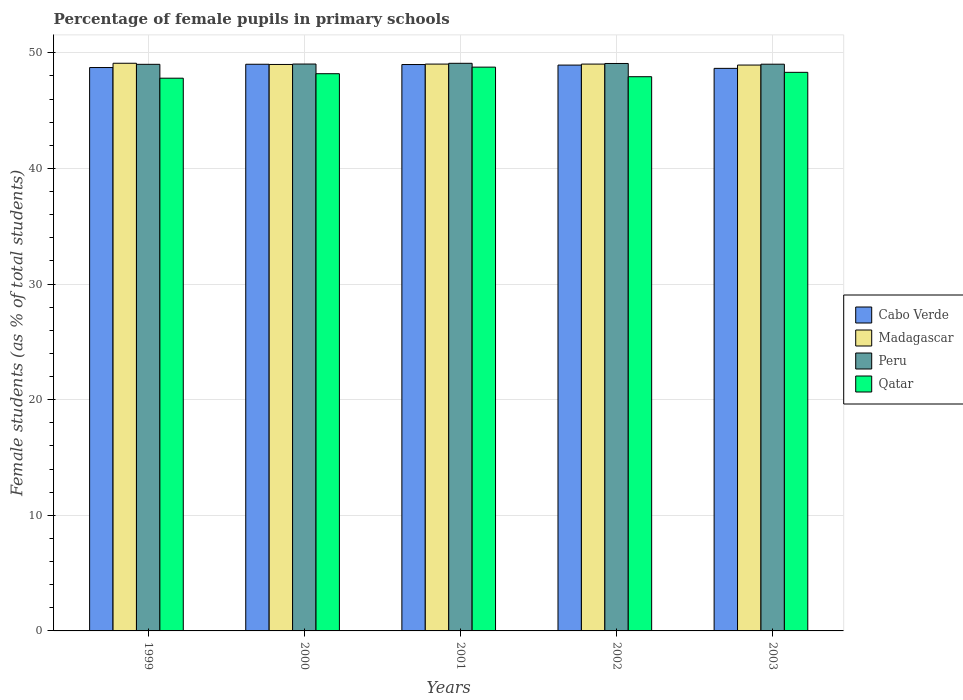Are the number of bars on each tick of the X-axis equal?
Ensure brevity in your answer.  Yes. What is the percentage of female pupils in primary schools in Peru in 2003?
Provide a short and direct response. 49.02. Across all years, what is the maximum percentage of female pupils in primary schools in Madagascar?
Ensure brevity in your answer.  49.1. Across all years, what is the minimum percentage of female pupils in primary schools in Cabo Verde?
Keep it short and to the point. 48.66. In which year was the percentage of female pupils in primary schools in Qatar minimum?
Give a very brief answer. 1999. What is the total percentage of female pupils in primary schools in Cabo Verde in the graph?
Your response must be concise. 244.34. What is the difference between the percentage of female pupils in primary schools in Qatar in 1999 and that in 2000?
Provide a succinct answer. -0.39. What is the difference between the percentage of female pupils in primary schools in Qatar in 2002 and the percentage of female pupils in primary schools in Peru in 1999?
Your answer should be very brief. -1.07. What is the average percentage of female pupils in primary schools in Qatar per year?
Keep it short and to the point. 48.21. In the year 2003, what is the difference between the percentage of female pupils in primary schools in Qatar and percentage of female pupils in primary schools in Cabo Verde?
Keep it short and to the point. -0.34. In how many years, is the percentage of female pupils in primary schools in Qatar greater than 44 %?
Provide a short and direct response. 5. What is the ratio of the percentage of female pupils in primary schools in Cabo Verde in 2000 to that in 2002?
Give a very brief answer. 1. What is the difference between the highest and the second highest percentage of female pupils in primary schools in Cabo Verde?
Provide a short and direct response. 0.02. What is the difference between the highest and the lowest percentage of female pupils in primary schools in Cabo Verde?
Your response must be concise. 0.36. In how many years, is the percentage of female pupils in primary schools in Qatar greater than the average percentage of female pupils in primary schools in Qatar taken over all years?
Offer a very short reply. 2. Is it the case that in every year, the sum of the percentage of female pupils in primary schools in Peru and percentage of female pupils in primary schools in Cabo Verde is greater than the sum of percentage of female pupils in primary schools in Madagascar and percentage of female pupils in primary schools in Qatar?
Ensure brevity in your answer.  Yes. What does the 1st bar from the left in 2003 represents?
Make the answer very short. Cabo Verde. What does the 4th bar from the right in 2001 represents?
Your answer should be compact. Cabo Verde. Is it the case that in every year, the sum of the percentage of female pupils in primary schools in Madagascar and percentage of female pupils in primary schools in Peru is greater than the percentage of female pupils in primary schools in Cabo Verde?
Your answer should be very brief. Yes. How many bars are there?
Offer a terse response. 20. How many years are there in the graph?
Your answer should be compact. 5. How many legend labels are there?
Your answer should be very brief. 4. What is the title of the graph?
Keep it short and to the point. Percentage of female pupils in primary schools. What is the label or title of the X-axis?
Provide a succinct answer. Years. What is the label or title of the Y-axis?
Your answer should be very brief. Female students (as % of total students). What is the Female students (as % of total students) of Cabo Verde in 1999?
Your answer should be compact. 48.73. What is the Female students (as % of total students) of Madagascar in 1999?
Your answer should be compact. 49.1. What is the Female students (as % of total students) of Peru in 1999?
Your answer should be very brief. 49.01. What is the Female students (as % of total students) of Qatar in 1999?
Keep it short and to the point. 47.81. What is the Female students (as % of total students) in Cabo Verde in 2000?
Your answer should be very brief. 49.01. What is the Female students (as % of total students) of Madagascar in 2000?
Offer a very short reply. 49. What is the Female students (as % of total students) of Peru in 2000?
Make the answer very short. 49.03. What is the Female students (as % of total students) of Qatar in 2000?
Offer a very short reply. 48.2. What is the Female students (as % of total students) of Cabo Verde in 2001?
Provide a succinct answer. 48.99. What is the Female students (as % of total students) in Madagascar in 2001?
Keep it short and to the point. 49.03. What is the Female students (as % of total students) in Peru in 2001?
Your answer should be compact. 49.1. What is the Female students (as % of total students) in Qatar in 2001?
Offer a very short reply. 48.77. What is the Female students (as % of total students) in Cabo Verde in 2002?
Offer a terse response. 48.94. What is the Female students (as % of total students) in Madagascar in 2002?
Offer a terse response. 49.03. What is the Female students (as % of total students) in Peru in 2002?
Provide a succinct answer. 49.08. What is the Female students (as % of total students) in Qatar in 2002?
Offer a very short reply. 47.94. What is the Female students (as % of total students) in Cabo Verde in 2003?
Offer a very short reply. 48.66. What is the Female students (as % of total students) of Madagascar in 2003?
Offer a very short reply. 48.95. What is the Female students (as % of total students) in Peru in 2003?
Your answer should be compact. 49.02. What is the Female students (as % of total students) in Qatar in 2003?
Your answer should be very brief. 48.32. Across all years, what is the maximum Female students (as % of total students) of Cabo Verde?
Provide a succinct answer. 49.01. Across all years, what is the maximum Female students (as % of total students) in Madagascar?
Provide a short and direct response. 49.1. Across all years, what is the maximum Female students (as % of total students) of Peru?
Offer a terse response. 49.1. Across all years, what is the maximum Female students (as % of total students) in Qatar?
Make the answer very short. 48.77. Across all years, what is the minimum Female students (as % of total students) in Cabo Verde?
Offer a terse response. 48.66. Across all years, what is the minimum Female students (as % of total students) in Madagascar?
Offer a terse response. 48.95. Across all years, what is the minimum Female students (as % of total students) in Peru?
Give a very brief answer. 49.01. Across all years, what is the minimum Female students (as % of total students) in Qatar?
Your response must be concise. 47.81. What is the total Female students (as % of total students) in Cabo Verde in the graph?
Ensure brevity in your answer.  244.34. What is the total Female students (as % of total students) in Madagascar in the graph?
Offer a very short reply. 245.1. What is the total Female students (as % of total students) in Peru in the graph?
Make the answer very short. 245.24. What is the total Female students (as % of total students) in Qatar in the graph?
Make the answer very short. 241.03. What is the difference between the Female students (as % of total students) of Cabo Verde in 1999 and that in 2000?
Give a very brief answer. -0.28. What is the difference between the Female students (as % of total students) in Madagascar in 1999 and that in 2000?
Provide a short and direct response. 0.1. What is the difference between the Female students (as % of total students) of Peru in 1999 and that in 2000?
Ensure brevity in your answer.  -0.02. What is the difference between the Female students (as % of total students) of Qatar in 1999 and that in 2000?
Your response must be concise. -0.39. What is the difference between the Female students (as % of total students) of Cabo Verde in 1999 and that in 2001?
Keep it short and to the point. -0.26. What is the difference between the Female students (as % of total students) in Madagascar in 1999 and that in 2001?
Keep it short and to the point. 0.07. What is the difference between the Female students (as % of total students) in Peru in 1999 and that in 2001?
Your response must be concise. -0.09. What is the difference between the Female students (as % of total students) of Qatar in 1999 and that in 2001?
Make the answer very short. -0.96. What is the difference between the Female students (as % of total students) of Cabo Verde in 1999 and that in 2002?
Your answer should be compact. -0.21. What is the difference between the Female students (as % of total students) of Madagascar in 1999 and that in 2002?
Your answer should be compact. 0.07. What is the difference between the Female students (as % of total students) in Peru in 1999 and that in 2002?
Provide a short and direct response. -0.07. What is the difference between the Female students (as % of total students) of Qatar in 1999 and that in 2002?
Ensure brevity in your answer.  -0.13. What is the difference between the Female students (as % of total students) in Cabo Verde in 1999 and that in 2003?
Provide a short and direct response. 0.07. What is the difference between the Female students (as % of total students) in Madagascar in 1999 and that in 2003?
Provide a short and direct response. 0.16. What is the difference between the Female students (as % of total students) in Peru in 1999 and that in 2003?
Keep it short and to the point. -0.01. What is the difference between the Female students (as % of total students) of Qatar in 1999 and that in 2003?
Give a very brief answer. -0.51. What is the difference between the Female students (as % of total students) of Cabo Verde in 2000 and that in 2001?
Keep it short and to the point. 0.02. What is the difference between the Female students (as % of total students) of Madagascar in 2000 and that in 2001?
Your response must be concise. -0.03. What is the difference between the Female students (as % of total students) of Peru in 2000 and that in 2001?
Provide a succinct answer. -0.06. What is the difference between the Female students (as % of total students) of Qatar in 2000 and that in 2001?
Ensure brevity in your answer.  -0.57. What is the difference between the Female students (as % of total students) of Cabo Verde in 2000 and that in 2002?
Make the answer very short. 0.07. What is the difference between the Female students (as % of total students) in Madagascar in 2000 and that in 2002?
Offer a very short reply. -0.03. What is the difference between the Female students (as % of total students) of Peru in 2000 and that in 2002?
Ensure brevity in your answer.  -0.05. What is the difference between the Female students (as % of total students) in Qatar in 2000 and that in 2002?
Your answer should be compact. 0.26. What is the difference between the Female students (as % of total students) in Cabo Verde in 2000 and that in 2003?
Your response must be concise. 0.35. What is the difference between the Female students (as % of total students) in Madagascar in 2000 and that in 2003?
Ensure brevity in your answer.  0.05. What is the difference between the Female students (as % of total students) of Peru in 2000 and that in 2003?
Offer a very short reply. 0.01. What is the difference between the Female students (as % of total students) of Qatar in 2000 and that in 2003?
Ensure brevity in your answer.  -0.12. What is the difference between the Female students (as % of total students) of Cabo Verde in 2001 and that in 2002?
Your response must be concise. 0.05. What is the difference between the Female students (as % of total students) in Madagascar in 2001 and that in 2002?
Your answer should be compact. 0. What is the difference between the Female students (as % of total students) of Peru in 2001 and that in 2002?
Your answer should be very brief. 0.01. What is the difference between the Female students (as % of total students) in Qatar in 2001 and that in 2002?
Keep it short and to the point. 0.83. What is the difference between the Female students (as % of total students) of Cabo Verde in 2001 and that in 2003?
Offer a terse response. 0.33. What is the difference between the Female students (as % of total students) in Madagascar in 2001 and that in 2003?
Give a very brief answer. 0.08. What is the difference between the Female students (as % of total students) of Peru in 2001 and that in 2003?
Provide a succinct answer. 0.08. What is the difference between the Female students (as % of total students) of Qatar in 2001 and that in 2003?
Keep it short and to the point. 0.45. What is the difference between the Female students (as % of total students) in Cabo Verde in 2002 and that in 2003?
Offer a terse response. 0.28. What is the difference between the Female students (as % of total students) of Madagascar in 2002 and that in 2003?
Make the answer very short. 0.08. What is the difference between the Female students (as % of total students) in Peru in 2002 and that in 2003?
Keep it short and to the point. 0.06. What is the difference between the Female students (as % of total students) in Qatar in 2002 and that in 2003?
Provide a short and direct response. -0.38. What is the difference between the Female students (as % of total students) of Cabo Verde in 1999 and the Female students (as % of total students) of Madagascar in 2000?
Provide a succinct answer. -0.27. What is the difference between the Female students (as % of total students) in Cabo Verde in 1999 and the Female students (as % of total students) in Peru in 2000?
Your answer should be very brief. -0.3. What is the difference between the Female students (as % of total students) of Cabo Verde in 1999 and the Female students (as % of total students) of Qatar in 2000?
Provide a succinct answer. 0.53. What is the difference between the Female students (as % of total students) of Madagascar in 1999 and the Female students (as % of total students) of Peru in 2000?
Your answer should be compact. 0.07. What is the difference between the Female students (as % of total students) in Madagascar in 1999 and the Female students (as % of total students) in Qatar in 2000?
Your answer should be compact. 0.9. What is the difference between the Female students (as % of total students) in Peru in 1999 and the Female students (as % of total students) in Qatar in 2000?
Your answer should be very brief. 0.81. What is the difference between the Female students (as % of total students) in Cabo Verde in 1999 and the Female students (as % of total students) in Madagascar in 2001?
Your answer should be very brief. -0.3. What is the difference between the Female students (as % of total students) in Cabo Verde in 1999 and the Female students (as % of total students) in Peru in 2001?
Offer a terse response. -0.37. What is the difference between the Female students (as % of total students) in Cabo Verde in 1999 and the Female students (as % of total students) in Qatar in 2001?
Offer a terse response. -0.03. What is the difference between the Female students (as % of total students) of Madagascar in 1999 and the Female students (as % of total students) of Peru in 2001?
Your answer should be compact. 0. What is the difference between the Female students (as % of total students) of Madagascar in 1999 and the Female students (as % of total students) of Qatar in 2001?
Offer a terse response. 0.34. What is the difference between the Female students (as % of total students) in Peru in 1999 and the Female students (as % of total students) in Qatar in 2001?
Give a very brief answer. 0.24. What is the difference between the Female students (as % of total students) in Cabo Verde in 1999 and the Female students (as % of total students) in Madagascar in 2002?
Ensure brevity in your answer.  -0.3. What is the difference between the Female students (as % of total students) of Cabo Verde in 1999 and the Female students (as % of total students) of Peru in 2002?
Your response must be concise. -0.35. What is the difference between the Female students (as % of total students) in Cabo Verde in 1999 and the Female students (as % of total students) in Qatar in 2002?
Offer a very short reply. 0.79. What is the difference between the Female students (as % of total students) in Madagascar in 1999 and the Female students (as % of total students) in Peru in 2002?
Provide a short and direct response. 0.02. What is the difference between the Female students (as % of total students) of Madagascar in 1999 and the Female students (as % of total students) of Qatar in 2002?
Provide a short and direct response. 1.16. What is the difference between the Female students (as % of total students) of Peru in 1999 and the Female students (as % of total students) of Qatar in 2002?
Your answer should be compact. 1.07. What is the difference between the Female students (as % of total students) of Cabo Verde in 1999 and the Female students (as % of total students) of Madagascar in 2003?
Your answer should be very brief. -0.21. What is the difference between the Female students (as % of total students) in Cabo Verde in 1999 and the Female students (as % of total students) in Peru in 2003?
Your response must be concise. -0.29. What is the difference between the Female students (as % of total students) in Cabo Verde in 1999 and the Female students (as % of total students) in Qatar in 2003?
Your response must be concise. 0.42. What is the difference between the Female students (as % of total students) of Madagascar in 1999 and the Female students (as % of total students) of Peru in 2003?
Ensure brevity in your answer.  0.08. What is the difference between the Female students (as % of total students) in Madagascar in 1999 and the Female students (as % of total students) in Qatar in 2003?
Offer a very short reply. 0.79. What is the difference between the Female students (as % of total students) of Peru in 1999 and the Female students (as % of total students) of Qatar in 2003?
Keep it short and to the point. 0.69. What is the difference between the Female students (as % of total students) of Cabo Verde in 2000 and the Female students (as % of total students) of Madagascar in 2001?
Your response must be concise. -0.02. What is the difference between the Female students (as % of total students) of Cabo Verde in 2000 and the Female students (as % of total students) of Peru in 2001?
Provide a short and direct response. -0.08. What is the difference between the Female students (as % of total students) in Cabo Verde in 2000 and the Female students (as % of total students) in Qatar in 2001?
Keep it short and to the point. 0.25. What is the difference between the Female students (as % of total students) of Madagascar in 2000 and the Female students (as % of total students) of Qatar in 2001?
Ensure brevity in your answer.  0.23. What is the difference between the Female students (as % of total students) in Peru in 2000 and the Female students (as % of total students) in Qatar in 2001?
Provide a short and direct response. 0.27. What is the difference between the Female students (as % of total students) of Cabo Verde in 2000 and the Female students (as % of total students) of Madagascar in 2002?
Your response must be concise. -0.02. What is the difference between the Female students (as % of total students) in Cabo Verde in 2000 and the Female students (as % of total students) in Peru in 2002?
Offer a very short reply. -0.07. What is the difference between the Female students (as % of total students) in Cabo Verde in 2000 and the Female students (as % of total students) in Qatar in 2002?
Give a very brief answer. 1.08. What is the difference between the Female students (as % of total students) of Madagascar in 2000 and the Female students (as % of total students) of Peru in 2002?
Keep it short and to the point. -0.09. What is the difference between the Female students (as % of total students) in Madagascar in 2000 and the Female students (as % of total students) in Qatar in 2002?
Make the answer very short. 1.06. What is the difference between the Female students (as % of total students) of Peru in 2000 and the Female students (as % of total students) of Qatar in 2002?
Offer a very short reply. 1.1. What is the difference between the Female students (as % of total students) in Cabo Verde in 2000 and the Female students (as % of total students) in Madagascar in 2003?
Your answer should be very brief. 0.07. What is the difference between the Female students (as % of total students) in Cabo Verde in 2000 and the Female students (as % of total students) in Peru in 2003?
Ensure brevity in your answer.  -0.01. What is the difference between the Female students (as % of total students) in Cabo Verde in 2000 and the Female students (as % of total students) in Qatar in 2003?
Your response must be concise. 0.7. What is the difference between the Female students (as % of total students) in Madagascar in 2000 and the Female students (as % of total students) in Peru in 2003?
Provide a short and direct response. -0.02. What is the difference between the Female students (as % of total students) of Madagascar in 2000 and the Female students (as % of total students) of Qatar in 2003?
Offer a very short reply. 0.68. What is the difference between the Female students (as % of total students) of Peru in 2000 and the Female students (as % of total students) of Qatar in 2003?
Make the answer very short. 0.72. What is the difference between the Female students (as % of total students) in Cabo Verde in 2001 and the Female students (as % of total students) in Madagascar in 2002?
Your response must be concise. -0.04. What is the difference between the Female students (as % of total students) of Cabo Verde in 2001 and the Female students (as % of total students) of Peru in 2002?
Give a very brief answer. -0.09. What is the difference between the Female students (as % of total students) of Cabo Verde in 2001 and the Female students (as % of total students) of Qatar in 2002?
Provide a short and direct response. 1.05. What is the difference between the Female students (as % of total students) in Madagascar in 2001 and the Female students (as % of total students) in Peru in 2002?
Your response must be concise. -0.05. What is the difference between the Female students (as % of total students) of Madagascar in 2001 and the Female students (as % of total students) of Qatar in 2002?
Provide a short and direct response. 1.09. What is the difference between the Female students (as % of total students) of Peru in 2001 and the Female students (as % of total students) of Qatar in 2002?
Ensure brevity in your answer.  1.16. What is the difference between the Female students (as % of total students) of Cabo Verde in 2001 and the Female students (as % of total students) of Madagascar in 2003?
Your answer should be compact. 0.04. What is the difference between the Female students (as % of total students) in Cabo Verde in 2001 and the Female students (as % of total students) in Peru in 2003?
Ensure brevity in your answer.  -0.03. What is the difference between the Female students (as % of total students) in Cabo Verde in 2001 and the Female students (as % of total students) in Qatar in 2003?
Ensure brevity in your answer.  0.67. What is the difference between the Female students (as % of total students) in Madagascar in 2001 and the Female students (as % of total students) in Peru in 2003?
Your answer should be compact. 0.01. What is the difference between the Female students (as % of total students) in Peru in 2001 and the Female students (as % of total students) in Qatar in 2003?
Provide a succinct answer. 0.78. What is the difference between the Female students (as % of total students) of Cabo Verde in 2002 and the Female students (as % of total students) of Madagascar in 2003?
Give a very brief answer. -0. What is the difference between the Female students (as % of total students) in Cabo Verde in 2002 and the Female students (as % of total students) in Peru in 2003?
Provide a short and direct response. -0.08. What is the difference between the Female students (as % of total students) of Cabo Verde in 2002 and the Female students (as % of total students) of Qatar in 2003?
Make the answer very short. 0.63. What is the difference between the Female students (as % of total students) in Madagascar in 2002 and the Female students (as % of total students) in Peru in 2003?
Provide a succinct answer. 0.01. What is the difference between the Female students (as % of total students) in Madagascar in 2002 and the Female students (as % of total students) in Qatar in 2003?
Provide a succinct answer. 0.71. What is the difference between the Female students (as % of total students) in Peru in 2002 and the Female students (as % of total students) in Qatar in 2003?
Your answer should be very brief. 0.77. What is the average Female students (as % of total students) of Cabo Verde per year?
Your response must be concise. 48.87. What is the average Female students (as % of total students) in Madagascar per year?
Offer a terse response. 49.02. What is the average Female students (as % of total students) in Peru per year?
Make the answer very short. 49.05. What is the average Female students (as % of total students) of Qatar per year?
Your response must be concise. 48.21. In the year 1999, what is the difference between the Female students (as % of total students) of Cabo Verde and Female students (as % of total students) of Madagascar?
Give a very brief answer. -0.37. In the year 1999, what is the difference between the Female students (as % of total students) of Cabo Verde and Female students (as % of total students) of Peru?
Ensure brevity in your answer.  -0.28. In the year 1999, what is the difference between the Female students (as % of total students) of Cabo Verde and Female students (as % of total students) of Qatar?
Make the answer very short. 0.92. In the year 1999, what is the difference between the Female students (as % of total students) in Madagascar and Female students (as % of total students) in Peru?
Make the answer very short. 0.09. In the year 1999, what is the difference between the Female students (as % of total students) in Madagascar and Female students (as % of total students) in Qatar?
Offer a terse response. 1.29. In the year 1999, what is the difference between the Female students (as % of total students) in Peru and Female students (as % of total students) in Qatar?
Ensure brevity in your answer.  1.2. In the year 2000, what is the difference between the Female students (as % of total students) in Cabo Verde and Female students (as % of total students) in Madagascar?
Provide a succinct answer. 0.02. In the year 2000, what is the difference between the Female students (as % of total students) of Cabo Verde and Female students (as % of total students) of Peru?
Ensure brevity in your answer.  -0.02. In the year 2000, what is the difference between the Female students (as % of total students) in Cabo Verde and Female students (as % of total students) in Qatar?
Your response must be concise. 0.82. In the year 2000, what is the difference between the Female students (as % of total students) in Madagascar and Female students (as % of total students) in Peru?
Your answer should be compact. -0.04. In the year 2000, what is the difference between the Female students (as % of total students) of Madagascar and Female students (as % of total students) of Qatar?
Give a very brief answer. 0.8. In the year 2000, what is the difference between the Female students (as % of total students) of Peru and Female students (as % of total students) of Qatar?
Give a very brief answer. 0.84. In the year 2001, what is the difference between the Female students (as % of total students) in Cabo Verde and Female students (as % of total students) in Madagascar?
Your answer should be compact. -0.04. In the year 2001, what is the difference between the Female students (as % of total students) in Cabo Verde and Female students (as % of total students) in Peru?
Your answer should be compact. -0.11. In the year 2001, what is the difference between the Female students (as % of total students) of Cabo Verde and Female students (as % of total students) of Qatar?
Provide a short and direct response. 0.22. In the year 2001, what is the difference between the Female students (as % of total students) in Madagascar and Female students (as % of total students) in Peru?
Give a very brief answer. -0.07. In the year 2001, what is the difference between the Female students (as % of total students) in Madagascar and Female students (as % of total students) in Qatar?
Your answer should be compact. 0.26. In the year 2001, what is the difference between the Female students (as % of total students) of Peru and Female students (as % of total students) of Qatar?
Provide a short and direct response. 0.33. In the year 2002, what is the difference between the Female students (as % of total students) in Cabo Verde and Female students (as % of total students) in Madagascar?
Keep it short and to the point. -0.09. In the year 2002, what is the difference between the Female students (as % of total students) in Cabo Verde and Female students (as % of total students) in Peru?
Provide a short and direct response. -0.14. In the year 2002, what is the difference between the Female students (as % of total students) of Cabo Verde and Female students (as % of total students) of Qatar?
Provide a succinct answer. 1.01. In the year 2002, what is the difference between the Female students (as % of total students) in Madagascar and Female students (as % of total students) in Peru?
Your response must be concise. -0.05. In the year 2002, what is the difference between the Female students (as % of total students) of Madagascar and Female students (as % of total students) of Qatar?
Your answer should be very brief. 1.09. In the year 2002, what is the difference between the Female students (as % of total students) of Peru and Female students (as % of total students) of Qatar?
Ensure brevity in your answer.  1.14. In the year 2003, what is the difference between the Female students (as % of total students) of Cabo Verde and Female students (as % of total students) of Madagascar?
Keep it short and to the point. -0.29. In the year 2003, what is the difference between the Female students (as % of total students) in Cabo Verde and Female students (as % of total students) in Peru?
Your response must be concise. -0.36. In the year 2003, what is the difference between the Female students (as % of total students) in Cabo Verde and Female students (as % of total students) in Qatar?
Provide a succinct answer. 0.34. In the year 2003, what is the difference between the Female students (as % of total students) in Madagascar and Female students (as % of total students) in Peru?
Keep it short and to the point. -0.07. In the year 2003, what is the difference between the Female students (as % of total students) of Madagascar and Female students (as % of total students) of Qatar?
Keep it short and to the point. 0.63. In the year 2003, what is the difference between the Female students (as % of total students) of Peru and Female students (as % of total students) of Qatar?
Your answer should be compact. 0.7. What is the ratio of the Female students (as % of total students) of Cabo Verde in 1999 to that in 2000?
Make the answer very short. 0.99. What is the ratio of the Female students (as % of total students) in Peru in 1999 to that in 2000?
Give a very brief answer. 1. What is the ratio of the Female students (as % of total students) in Cabo Verde in 1999 to that in 2001?
Keep it short and to the point. 0.99. What is the ratio of the Female students (as % of total students) in Qatar in 1999 to that in 2001?
Provide a short and direct response. 0.98. What is the ratio of the Female students (as % of total students) in Cabo Verde in 1999 to that in 2002?
Offer a very short reply. 1. What is the ratio of the Female students (as % of total students) of Madagascar in 1999 to that in 2002?
Ensure brevity in your answer.  1. What is the ratio of the Female students (as % of total students) of Peru in 1999 to that in 2002?
Your response must be concise. 1. What is the ratio of the Female students (as % of total students) in Madagascar in 1999 to that in 2003?
Offer a very short reply. 1. What is the ratio of the Female students (as % of total students) in Peru in 1999 to that in 2003?
Offer a very short reply. 1. What is the ratio of the Female students (as % of total students) in Qatar in 1999 to that in 2003?
Offer a terse response. 0.99. What is the ratio of the Female students (as % of total students) of Cabo Verde in 2000 to that in 2001?
Make the answer very short. 1. What is the ratio of the Female students (as % of total students) of Peru in 2000 to that in 2001?
Your response must be concise. 1. What is the ratio of the Female students (as % of total students) in Qatar in 2000 to that in 2001?
Offer a very short reply. 0.99. What is the ratio of the Female students (as % of total students) in Peru in 2000 to that in 2002?
Give a very brief answer. 1. What is the ratio of the Female students (as % of total students) of Qatar in 2000 to that in 2002?
Your response must be concise. 1.01. What is the ratio of the Female students (as % of total students) in Cabo Verde in 2000 to that in 2003?
Your answer should be very brief. 1.01. What is the ratio of the Female students (as % of total students) of Madagascar in 2000 to that in 2003?
Offer a terse response. 1. What is the ratio of the Female students (as % of total students) in Qatar in 2000 to that in 2003?
Make the answer very short. 1. What is the ratio of the Female students (as % of total students) in Cabo Verde in 2001 to that in 2002?
Ensure brevity in your answer.  1. What is the ratio of the Female students (as % of total students) in Madagascar in 2001 to that in 2002?
Ensure brevity in your answer.  1. What is the ratio of the Female students (as % of total students) in Qatar in 2001 to that in 2002?
Your response must be concise. 1.02. What is the ratio of the Female students (as % of total students) in Cabo Verde in 2001 to that in 2003?
Offer a very short reply. 1.01. What is the ratio of the Female students (as % of total students) in Qatar in 2001 to that in 2003?
Offer a terse response. 1.01. What is the difference between the highest and the second highest Female students (as % of total students) of Cabo Verde?
Give a very brief answer. 0.02. What is the difference between the highest and the second highest Female students (as % of total students) of Madagascar?
Offer a very short reply. 0.07. What is the difference between the highest and the second highest Female students (as % of total students) of Peru?
Ensure brevity in your answer.  0.01. What is the difference between the highest and the second highest Female students (as % of total students) of Qatar?
Give a very brief answer. 0.45. What is the difference between the highest and the lowest Female students (as % of total students) of Cabo Verde?
Provide a succinct answer. 0.35. What is the difference between the highest and the lowest Female students (as % of total students) in Madagascar?
Offer a terse response. 0.16. What is the difference between the highest and the lowest Female students (as % of total students) in Peru?
Offer a very short reply. 0.09. What is the difference between the highest and the lowest Female students (as % of total students) in Qatar?
Provide a succinct answer. 0.96. 